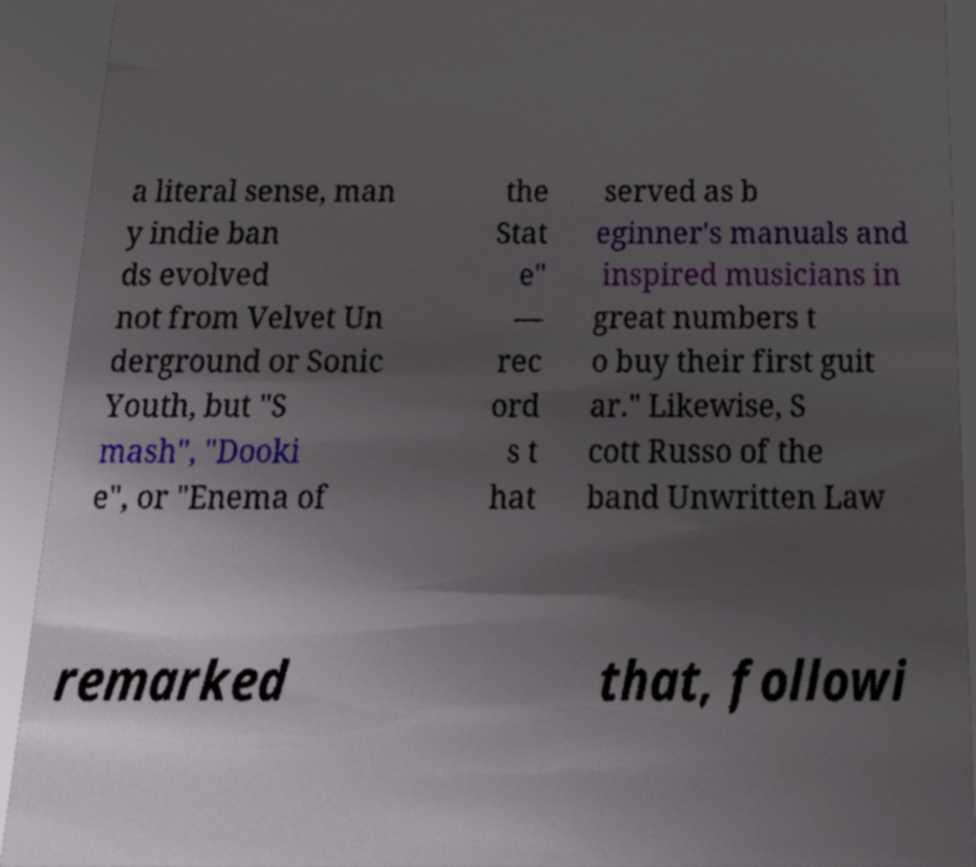Can you read and provide the text displayed in the image?This photo seems to have some interesting text. Can you extract and type it out for me? a literal sense, man y indie ban ds evolved not from Velvet Un derground or Sonic Youth, but "S mash", "Dooki e", or "Enema of the Stat e" — rec ord s t hat served as b eginner's manuals and inspired musicians in great numbers t o buy their first guit ar." Likewise, S cott Russo of the band Unwritten Law remarked that, followi 